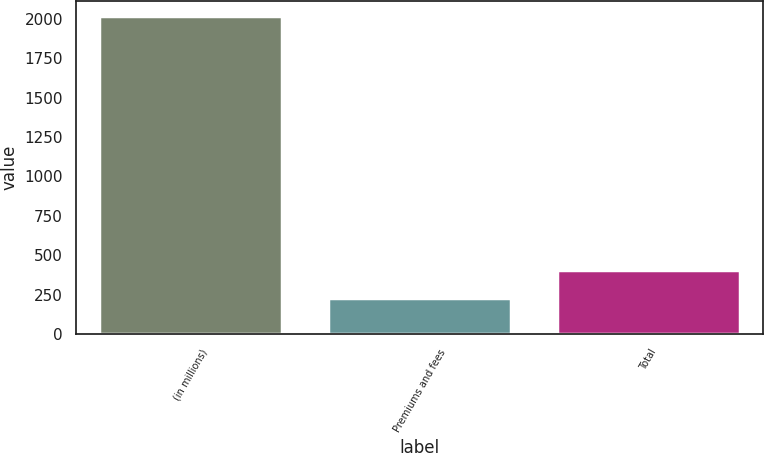Convert chart to OTSL. <chart><loc_0><loc_0><loc_500><loc_500><bar_chart><fcel>(in millions)<fcel>Premiums and fees<fcel>Total<nl><fcel>2015<fcel>226<fcel>404.9<nl></chart> 